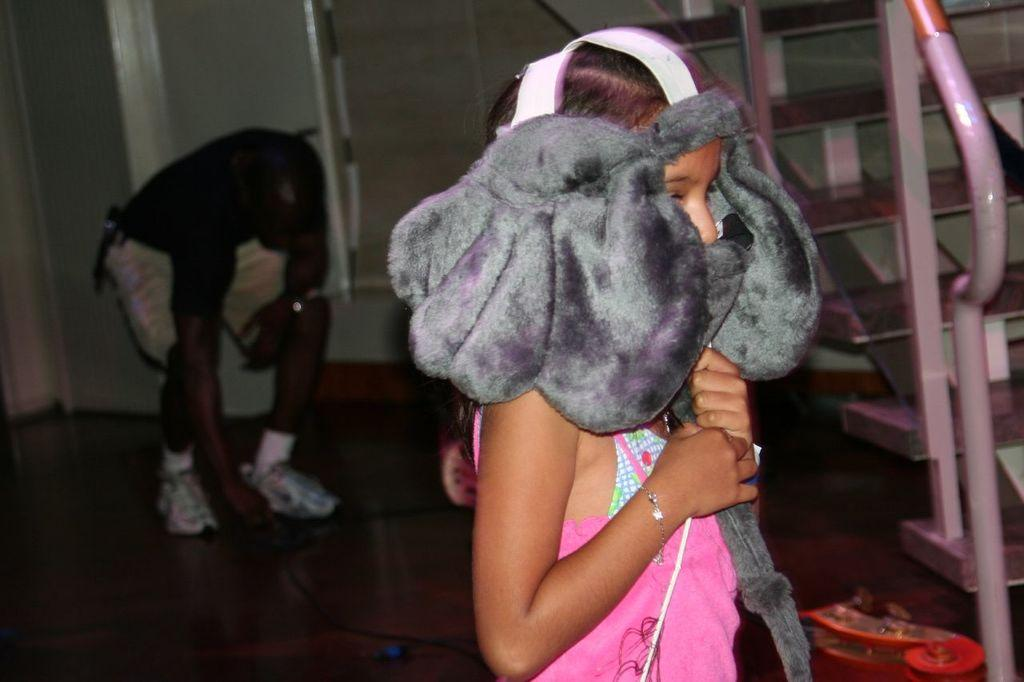Who is the main subject in the front of the image? There is a girl standing in the front of the image. What is the girl holding on her head? The girl is holding an object on her head. Can you describe the background of the image? There is a man, a wall, and steps in the background of the image. What grade is the girl in, based on the image? There is no information about the girl's grade in the image. Is the girl saying good-bye to someone in the image? There is no indication in the image that the girl is saying good-bye to someone. 